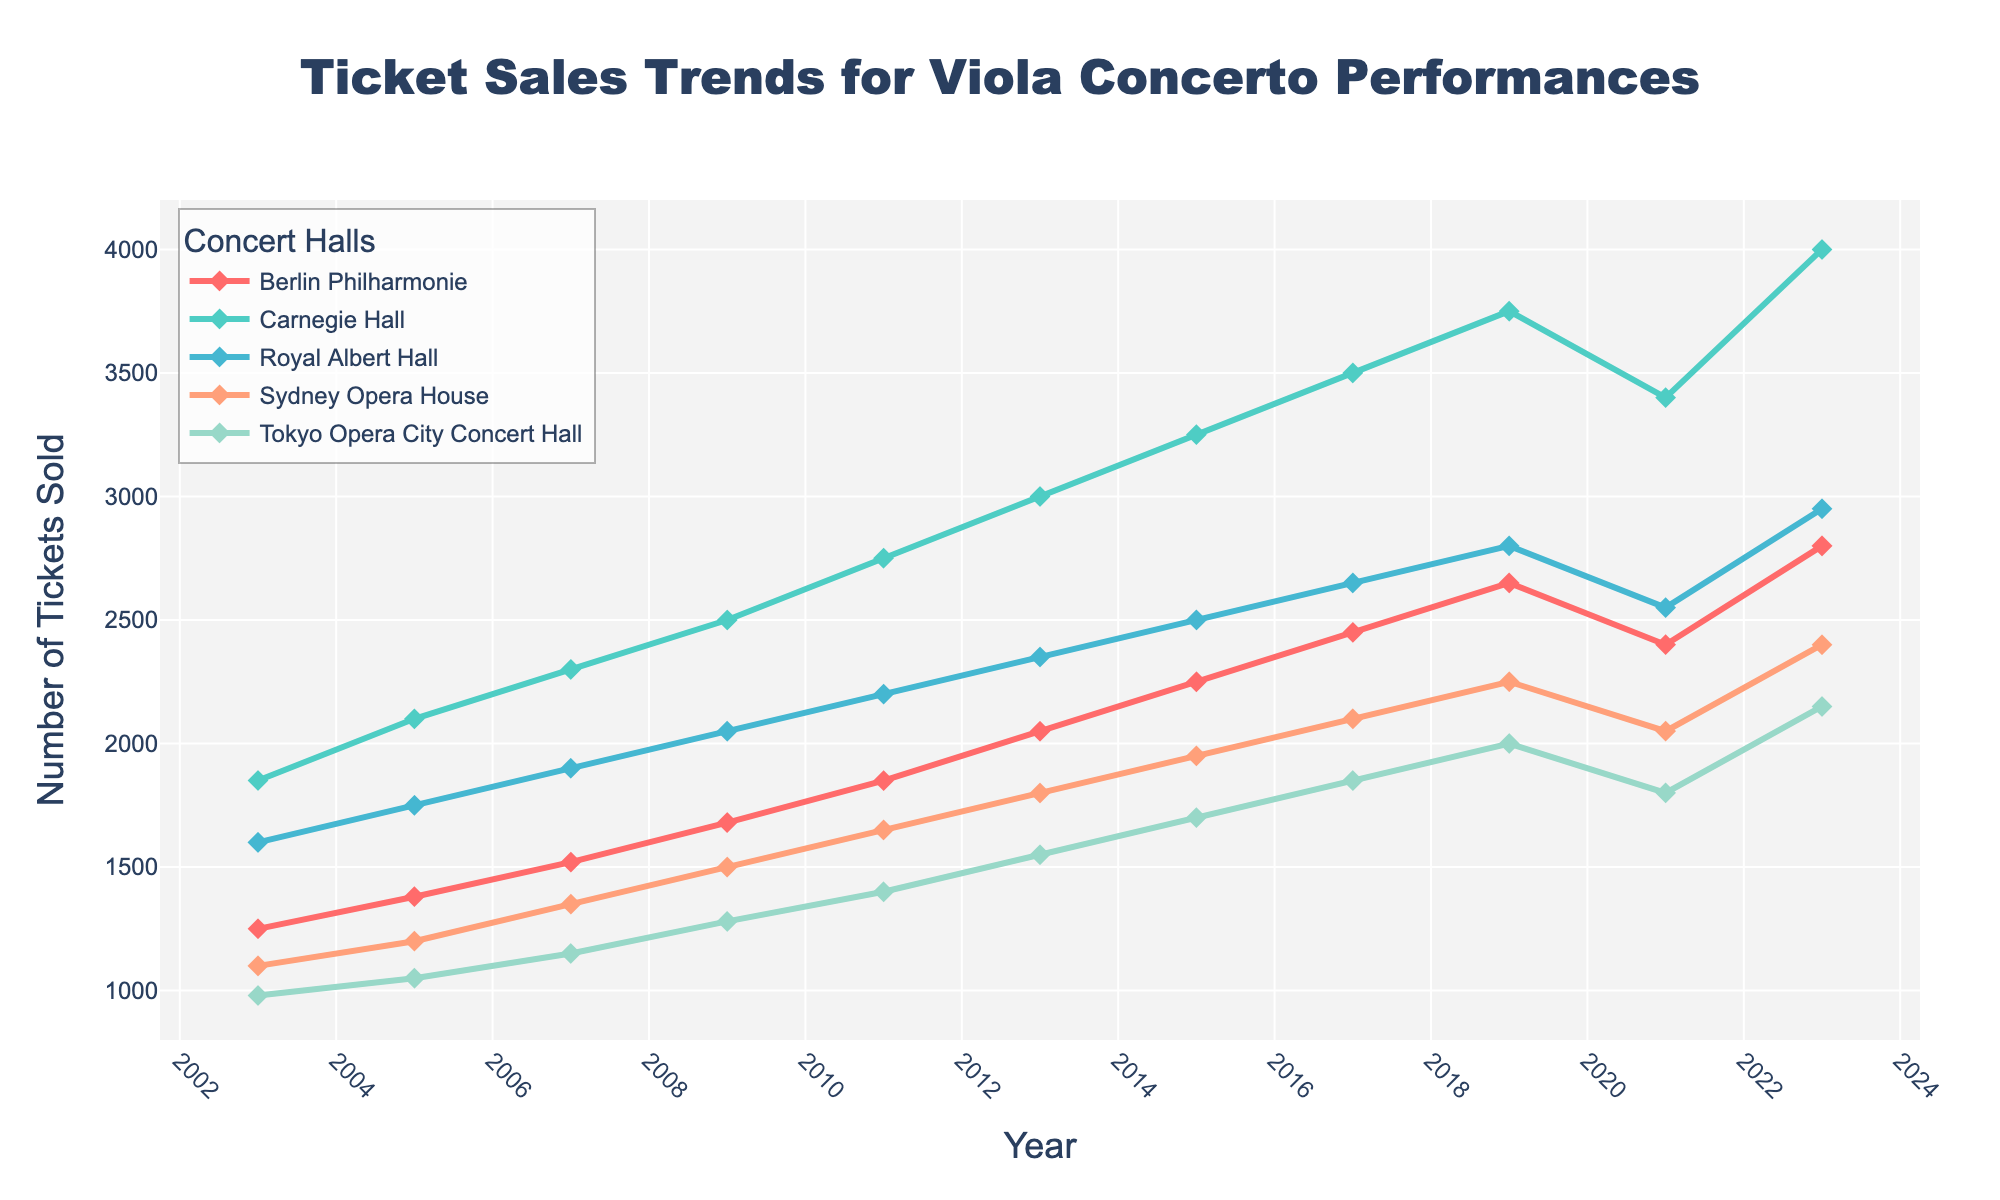What was the trend in ticket sales for the Berlin Philharmonie from 2003 to 2023? To determine the trend in ticket sales for the Berlin Philharmonie, observe the line plot representing this concert hall. From 2003 to 2021, there's a general upward trend, though a slight dip occurred in 2021. The overall trend resumes upward in 2023.
Answer: Upward trend with a slight dip in 2021 Which concert hall had the highest number of ticket sales in 2019? Look at the y-values corresponding to 2019 for each concert hall. The highest value among them is associated with Carnegie Hall.
Answer: Carnegie Hall Compare the ticket sales of Carnegie Hall and Royal Albert Hall in 2021. Which had more, and by how much? First, find the ticket sales for both Carnegie Hall and Royal Albert Hall in 2021. Carnegie Hall had 3400, and Royal Albert Hall had 2550. Subtract the smaller from the larger: 3400 - 2550 = 850.
Answer: Carnegie Hall by 850 What is the average number of tickets sold in 2023 across all concert halls? Sum the ticket sales in 2023: 2800 (Berlin Philharmonie) + 4000 (Carnegie Hall) + 2950 (Royal Albert Hall) + 2400 (Sydney Opera House) + 2150 (Tokyo Opera City Concert Hall). The total is 14,300. Divide by the number of halls (5): 14,300 / 5 = 2860.
Answer: 2860 Which concert hall experienced the most consistent growth in ticket sales over the two decades? Examine the lines representing each concert hall for the smoothness and lack of significant fluctuations. Berlin Philharmonie shows a steady increase without unusual spikes or dips, excluding the slight dip in 2021.
Answer: Berlin Philharmonie Identify the year in which Sydney Opera House ticket sales first reached 2000. Trace the line for Sydney Opera House and locate the point where it first crosses 2000 on the y-axis. This occurs in 2017.
Answer: 2017 How did ticket sales at Tokyo Opera City Concert Hall change between 2005 and 2023? Calculate the difference in ticket sales between these years: 2150 (2023) - 1050 (2005) = 1100. The ticket sales increased by 1100 during this period.
Answer: Increased by 1100 In which year was the smallest difference observed between the ticket sales of Berlin Philharmonie and Sydney Opera House? For each year, calculate the absolute difference between their ticket sales and find the smallest value. For example, in 2013:
Answer: 2013 During which period did Royal Albert Hall see its fastest growth in ticket sales? Identify the steepest section of the Royal Albert Hall line. The segment between 2005 and 2009 shows the most rapid increase.
Answer: 2005 to 2009 